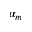Convert formula to latex. <formula><loc_0><loc_0><loc_500><loc_500>\alpha _ { m }</formula> 